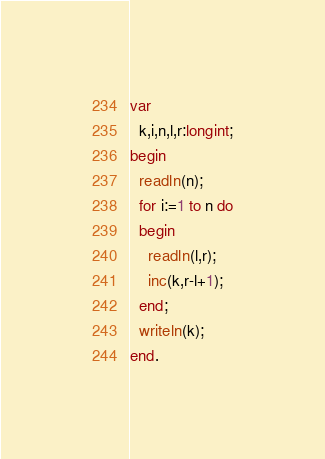<code> <loc_0><loc_0><loc_500><loc_500><_Pascal_>var
  k,i,n,l,r:longint;
begin
  readln(n);
  for i:=1 to n do
  begin
    readln(l,r);
    inc(k,r-l+1);
  end;
  writeln(k);
end.</code> 